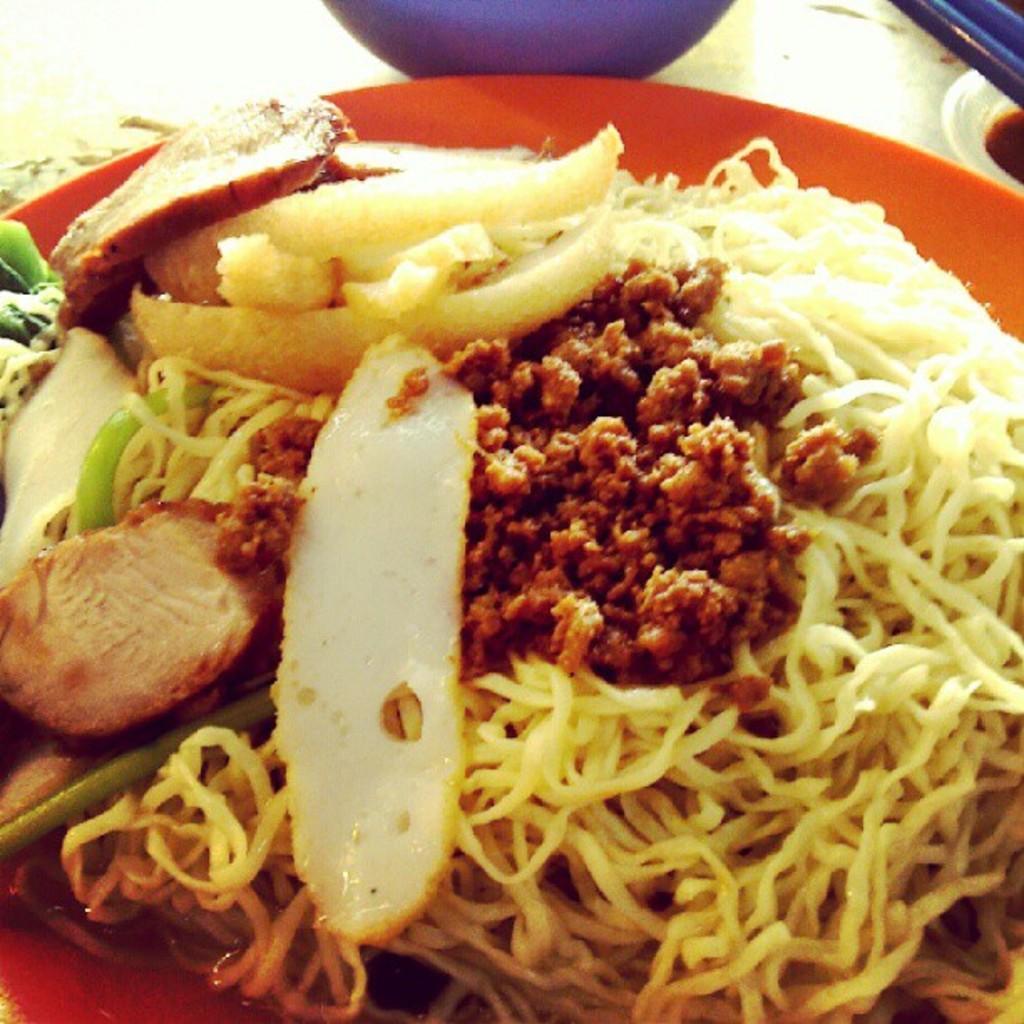Can you describe this image briefly? In this image there is a food item on the table. 